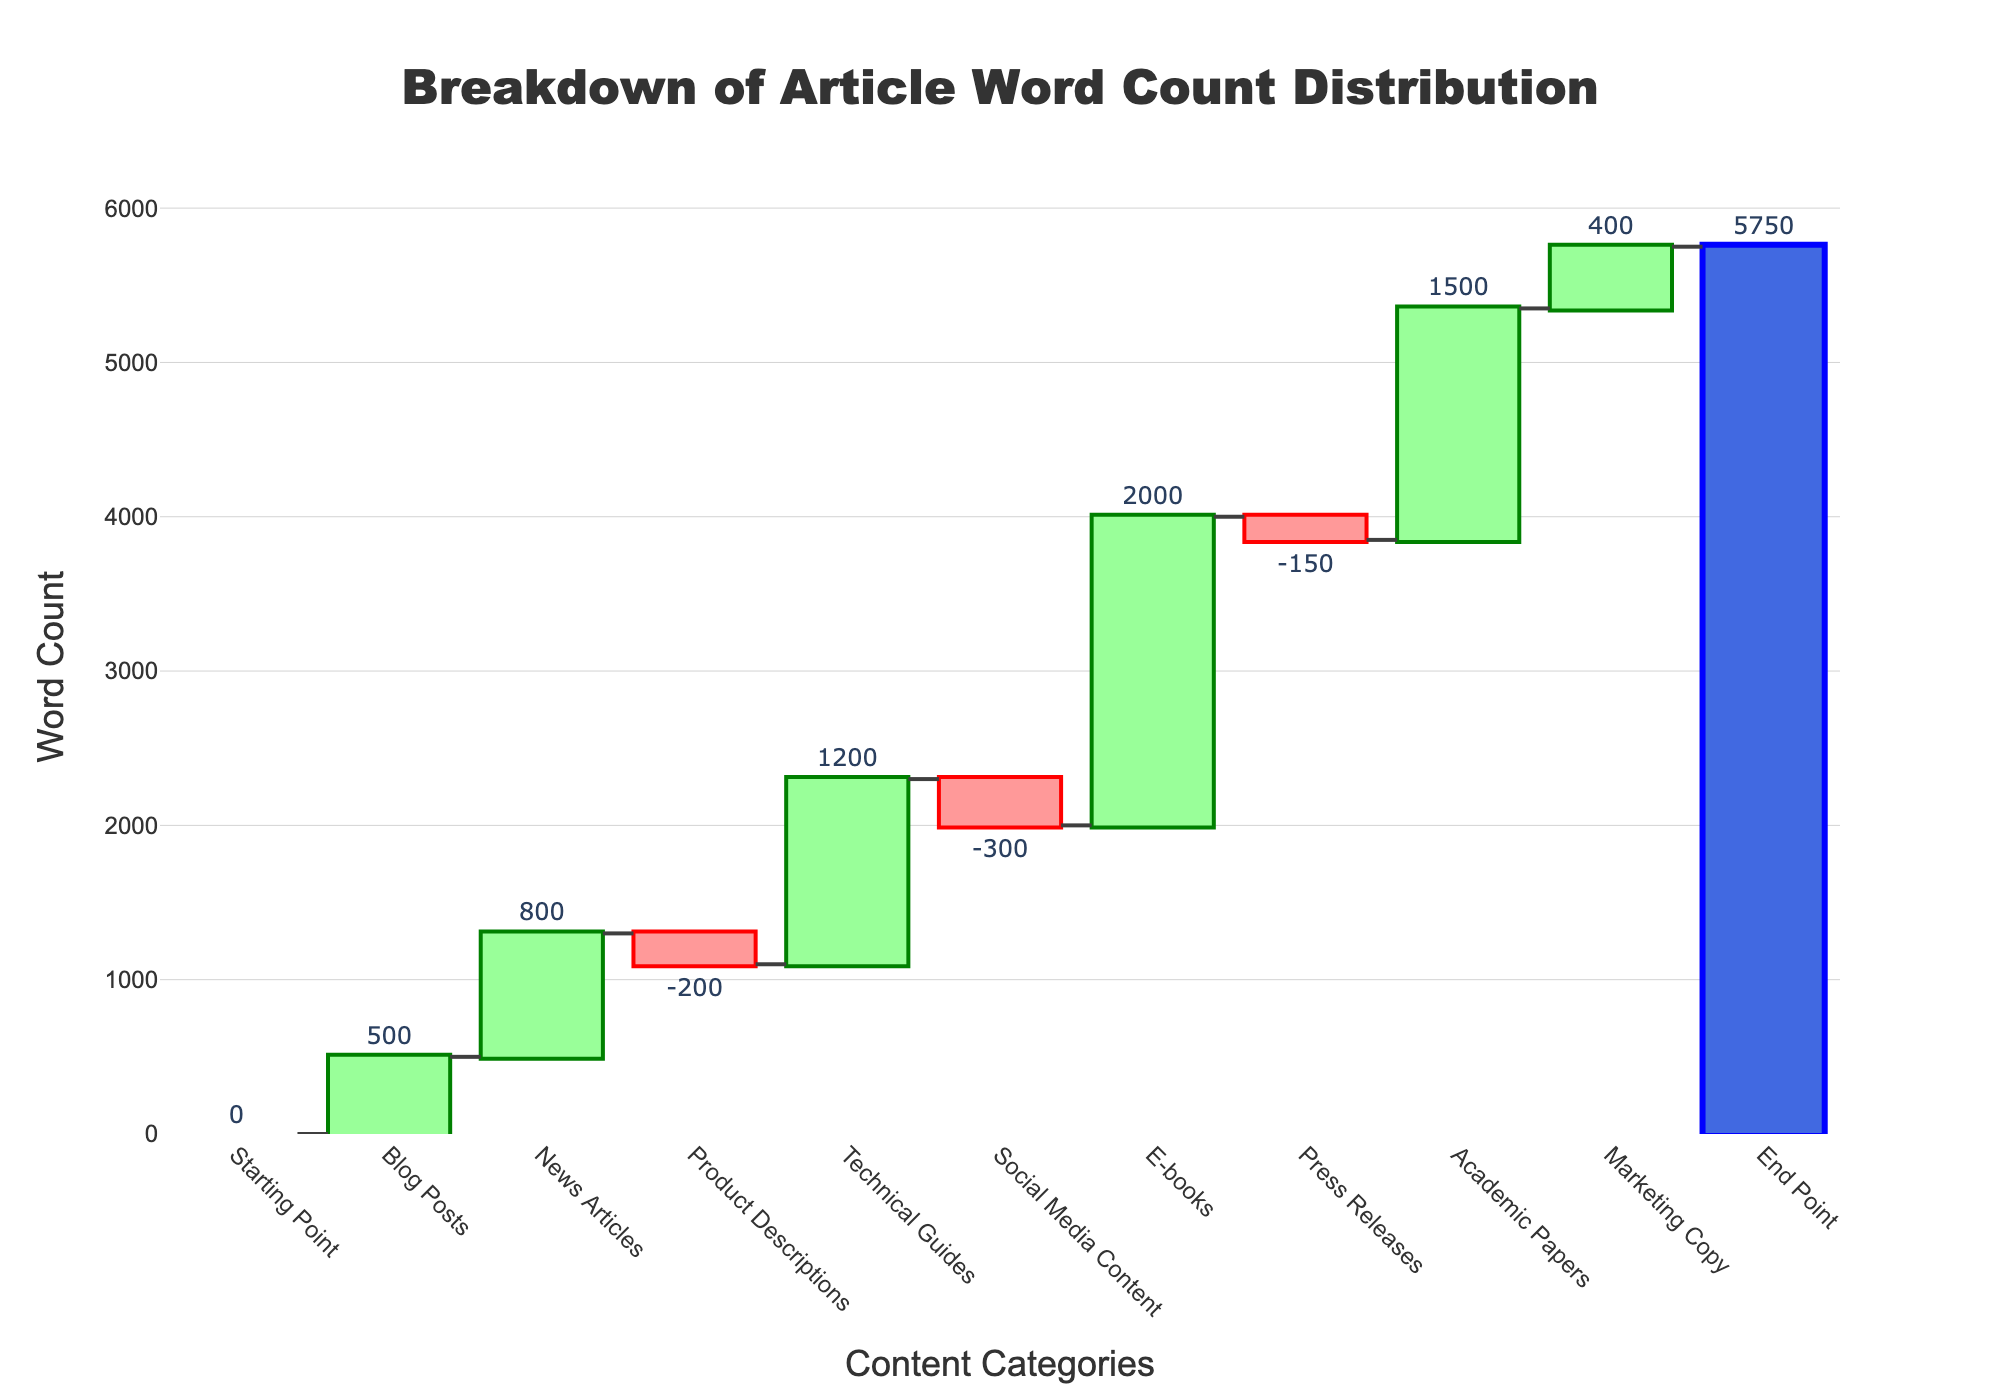What's the title of the chart? The title of the chart is displayed at the top center in large, bold text. It reads "Breakdown of Article Word Count Distribution".
Answer: Breakdown of Article Word Count Distribution What categories have a negative word count? The bars with negative values indicate the categories with a negative word count. These categories are "Product Descriptions", "Social Media Content", and "Press Releases".
Answer: Product Descriptions, Social Media Content, Press Releases What is the total word count by the end point? The total word count is shown at the final bar in the chart labeled "End Point". This bar aggregates the word counts from all categories and displays a value of 5750.
Answer: 5750 Which category has the highest contribution to the word count? By examining the heights of the bars, the category with the highest positive word count is "E-books" with a value of 2000.
Answer: E-books What is the difference in word count between News Articles and Blog Posts? To find the difference, subtract the word count of Blog Posts (500) from that of News Articles (800): 800 - 500 = 300.
Answer: 300 How did the word count change from the starting point to the end point? The starting point has a word count of 0, and the end point has a word count of 5750. Therefore, the total change is 5750 - 0 = 5750.
Answer: 5750 Which category added the least positive word count? Among the positive values, the category "Marketing Copy" has the least positive word count of 400.
Answer: Marketing Copy What is the combined word count of Blog Posts and Technical Guides? Add the word counts of Blog Posts (500) and Technical Guides (1200): 500 + 1200 = 1700.
Answer: 1700 What word count change does Social Media Content represent? Social Media Content has a negative word count of -300, meaning it reduces the overall word count by 300.
Answer: -300 Between Press Releases and Product Descriptions, which category has a larger negative impact, and by how much? Compare the negative word counts of Press Releases (-150) and Product Descriptions (-200). Product Descriptions have a larger negative impact. The difference is -200 - (-150) = -50.
Answer: Product Descriptions by 50 